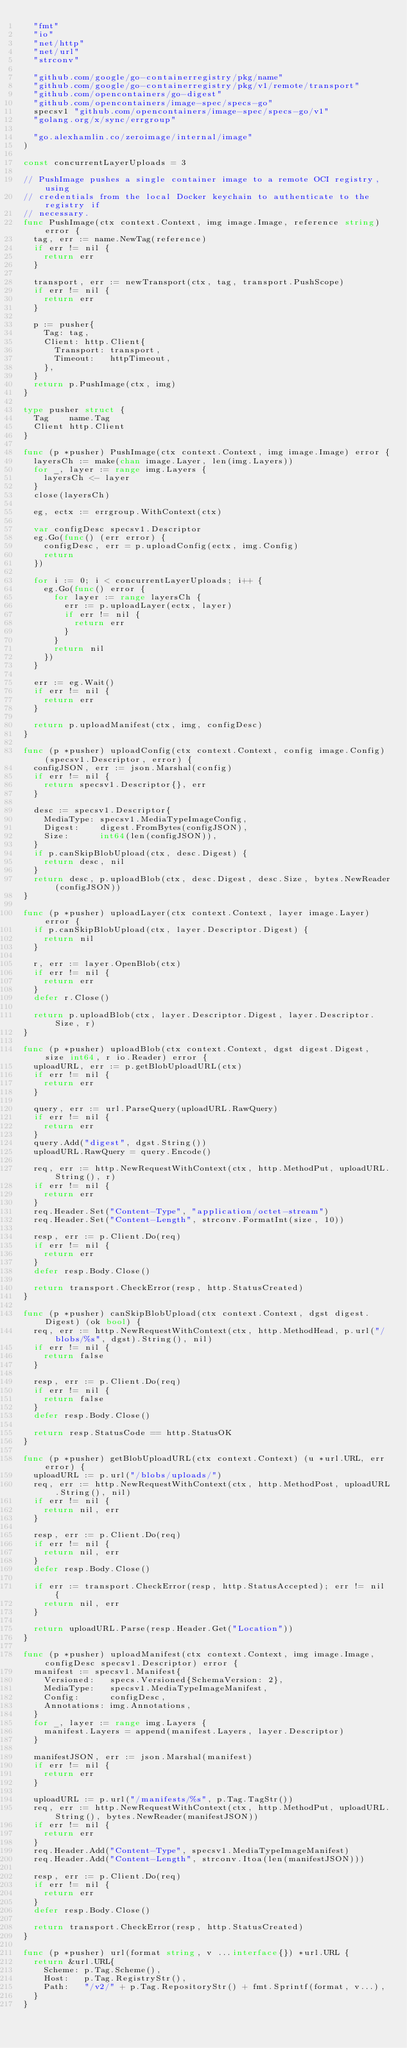Convert code to text. <code><loc_0><loc_0><loc_500><loc_500><_Go_>	"fmt"
	"io"
	"net/http"
	"net/url"
	"strconv"

	"github.com/google/go-containerregistry/pkg/name"
	"github.com/google/go-containerregistry/pkg/v1/remote/transport"
	"github.com/opencontainers/go-digest"
	"github.com/opencontainers/image-spec/specs-go"
	specsv1 "github.com/opencontainers/image-spec/specs-go/v1"
	"golang.org/x/sync/errgroup"

	"go.alexhamlin.co/zeroimage/internal/image"
)

const concurrentLayerUploads = 3

// PushImage pushes a single container image to a remote OCI registry, using
// credentials from the local Docker keychain to authenticate to the registry if
// necessary.
func PushImage(ctx context.Context, img image.Image, reference string) error {
	tag, err := name.NewTag(reference)
	if err != nil {
		return err
	}

	transport, err := newTransport(ctx, tag, transport.PushScope)
	if err != nil {
		return err
	}

	p := pusher{
		Tag: tag,
		Client: http.Client{
			Transport: transport,
			Timeout:   httpTimeout,
		},
	}
	return p.PushImage(ctx, img)
}

type pusher struct {
	Tag    name.Tag
	Client http.Client
}

func (p *pusher) PushImage(ctx context.Context, img image.Image) error {
	layersCh := make(chan image.Layer, len(img.Layers))
	for _, layer := range img.Layers {
		layersCh <- layer
	}
	close(layersCh)

	eg, ectx := errgroup.WithContext(ctx)

	var configDesc specsv1.Descriptor
	eg.Go(func() (err error) {
		configDesc, err = p.uploadConfig(ectx, img.Config)
		return
	})

	for i := 0; i < concurrentLayerUploads; i++ {
		eg.Go(func() error {
			for layer := range layersCh {
				err := p.uploadLayer(ectx, layer)
				if err != nil {
					return err
				}
			}
			return nil
		})
	}

	err := eg.Wait()
	if err != nil {
		return err
	}

	return p.uploadManifest(ctx, img, configDesc)
}

func (p *pusher) uploadConfig(ctx context.Context, config image.Config) (specsv1.Descriptor, error) {
	configJSON, err := json.Marshal(config)
	if err != nil {
		return specsv1.Descriptor{}, err
	}

	desc := specsv1.Descriptor{
		MediaType: specsv1.MediaTypeImageConfig,
		Digest:    digest.FromBytes(configJSON),
		Size:      int64(len(configJSON)),
	}
	if p.canSkipBlobUpload(ctx, desc.Digest) {
		return desc, nil
	}
	return desc, p.uploadBlob(ctx, desc.Digest, desc.Size, bytes.NewReader(configJSON))
}

func (p *pusher) uploadLayer(ctx context.Context, layer image.Layer) error {
	if p.canSkipBlobUpload(ctx, layer.Descriptor.Digest) {
		return nil
	}

	r, err := layer.OpenBlob(ctx)
	if err != nil {
		return err
	}
	defer r.Close()

	return p.uploadBlob(ctx, layer.Descriptor.Digest, layer.Descriptor.Size, r)
}

func (p *pusher) uploadBlob(ctx context.Context, dgst digest.Digest, size int64, r io.Reader) error {
	uploadURL, err := p.getBlobUploadURL(ctx)
	if err != nil {
		return err
	}

	query, err := url.ParseQuery(uploadURL.RawQuery)
	if err != nil {
		return err
	}
	query.Add("digest", dgst.String())
	uploadURL.RawQuery = query.Encode()

	req, err := http.NewRequestWithContext(ctx, http.MethodPut, uploadURL.String(), r)
	if err != nil {
		return err
	}
	req.Header.Set("Content-Type", "application/octet-stream")
	req.Header.Set("Content-Length", strconv.FormatInt(size, 10))

	resp, err := p.Client.Do(req)
	if err != nil {
		return err
	}
	defer resp.Body.Close()

	return transport.CheckError(resp, http.StatusCreated)
}

func (p *pusher) canSkipBlobUpload(ctx context.Context, dgst digest.Digest) (ok bool) {
	req, err := http.NewRequestWithContext(ctx, http.MethodHead, p.url("/blobs/%s", dgst).String(), nil)
	if err != nil {
		return false
	}

	resp, err := p.Client.Do(req)
	if err != nil {
		return false
	}
	defer resp.Body.Close()

	return resp.StatusCode == http.StatusOK
}

func (p *pusher) getBlobUploadURL(ctx context.Context) (u *url.URL, err error) {
	uploadURL := p.url("/blobs/uploads/")
	req, err := http.NewRequestWithContext(ctx, http.MethodPost, uploadURL.String(), nil)
	if err != nil {
		return nil, err
	}

	resp, err := p.Client.Do(req)
	if err != nil {
		return nil, err
	}
	defer resp.Body.Close()

	if err := transport.CheckError(resp, http.StatusAccepted); err != nil {
		return nil, err
	}

	return uploadURL.Parse(resp.Header.Get("Location"))
}

func (p *pusher) uploadManifest(ctx context.Context, img image.Image, configDesc specsv1.Descriptor) error {
	manifest := specsv1.Manifest{
		Versioned:   specs.Versioned{SchemaVersion: 2},
		MediaType:   specsv1.MediaTypeImageManifest,
		Config:      configDesc,
		Annotations: img.Annotations,
	}
	for _, layer := range img.Layers {
		manifest.Layers = append(manifest.Layers, layer.Descriptor)
	}

	manifestJSON, err := json.Marshal(manifest)
	if err != nil {
		return err
	}

	uploadURL := p.url("/manifests/%s", p.Tag.TagStr())
	req, err := http.NewRequestWithContext(ctx, http.MethodPut, uploadURL.String(), bytes.NewReader(manifestJSON))
	if err != nil {
		return err
	}
	req.Header.Add("Content-Type", specsv1.MediaTypeImageManifest)
	req.Header.Add("Content-Length", strconv.Itoa(len(manifestJSON)))

	resp, err := p.Client.Do(req)
	if err != nil {
		return err
	}
	defer resp.Body.Close()

	return transport.CheckError(resp, http.StatusCreated)
}

func (p *pusher) url(format string, v ...interface{}) *url.URL {
	return &url.URL{
		Scheme: p.Tag.Scheme(),
		Host:   p.Tag.RegistryStr(),
		Path:   "/v2/" + p.Tag.RepositoryStr() + fmt.Sprintf(format, v...),
	}
}
</code> 